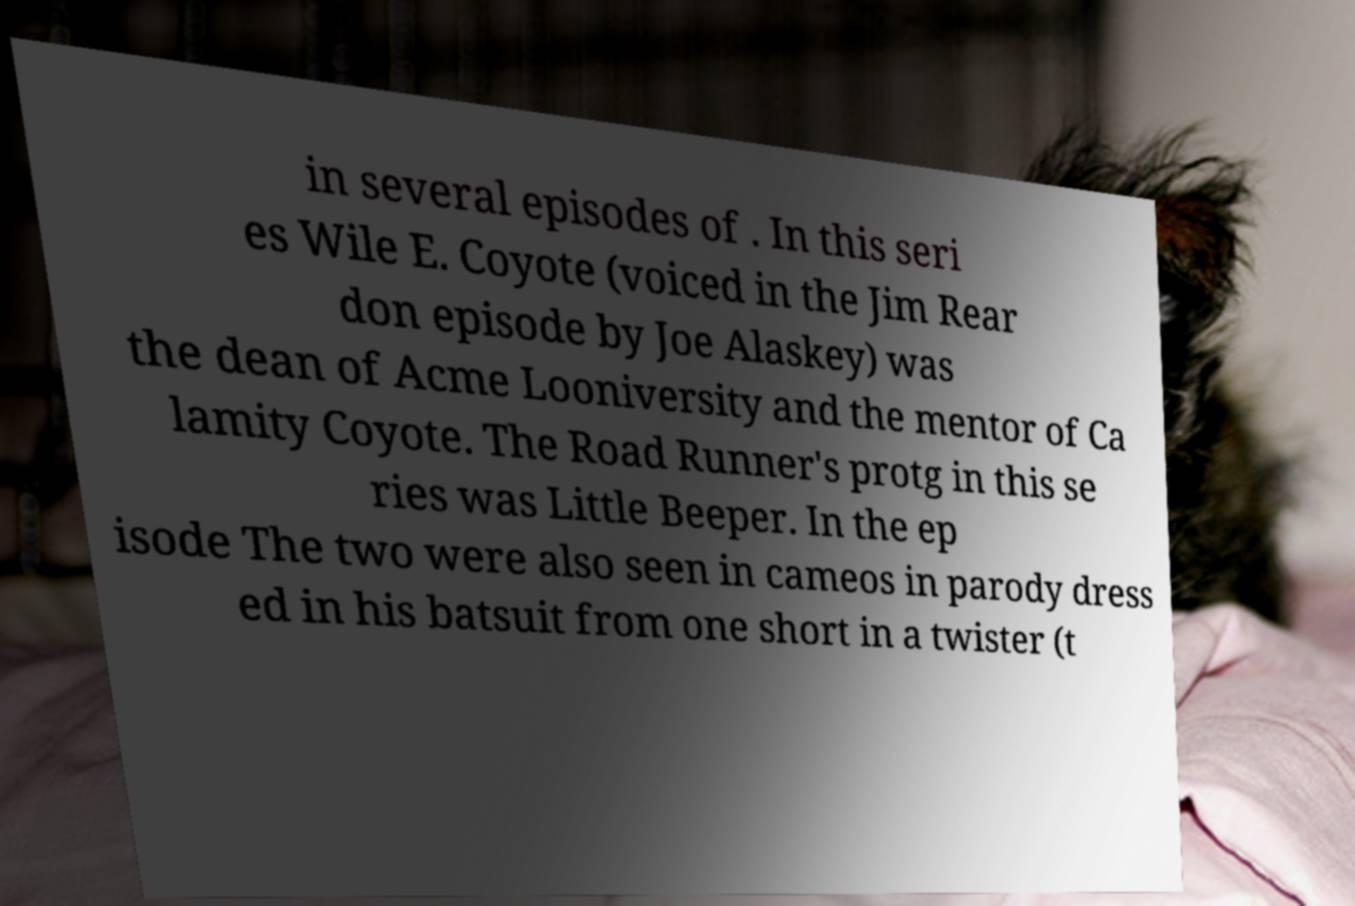For documentation purposes, I need the text within this image transcribed. Could you provide that? in several episodes of . In this seri es Wile E. Coyote (voiced in the Jim Rear don episode by Joe Alaskey) was the dean of Acme Looniversity and the mentor of Ca lamity Coyote. The Road Runner's protg in this se ries was Little Beeper. In the ep isode The two were also seen in cameos in parody dress ed in his batsuit from one short in a twister (t 